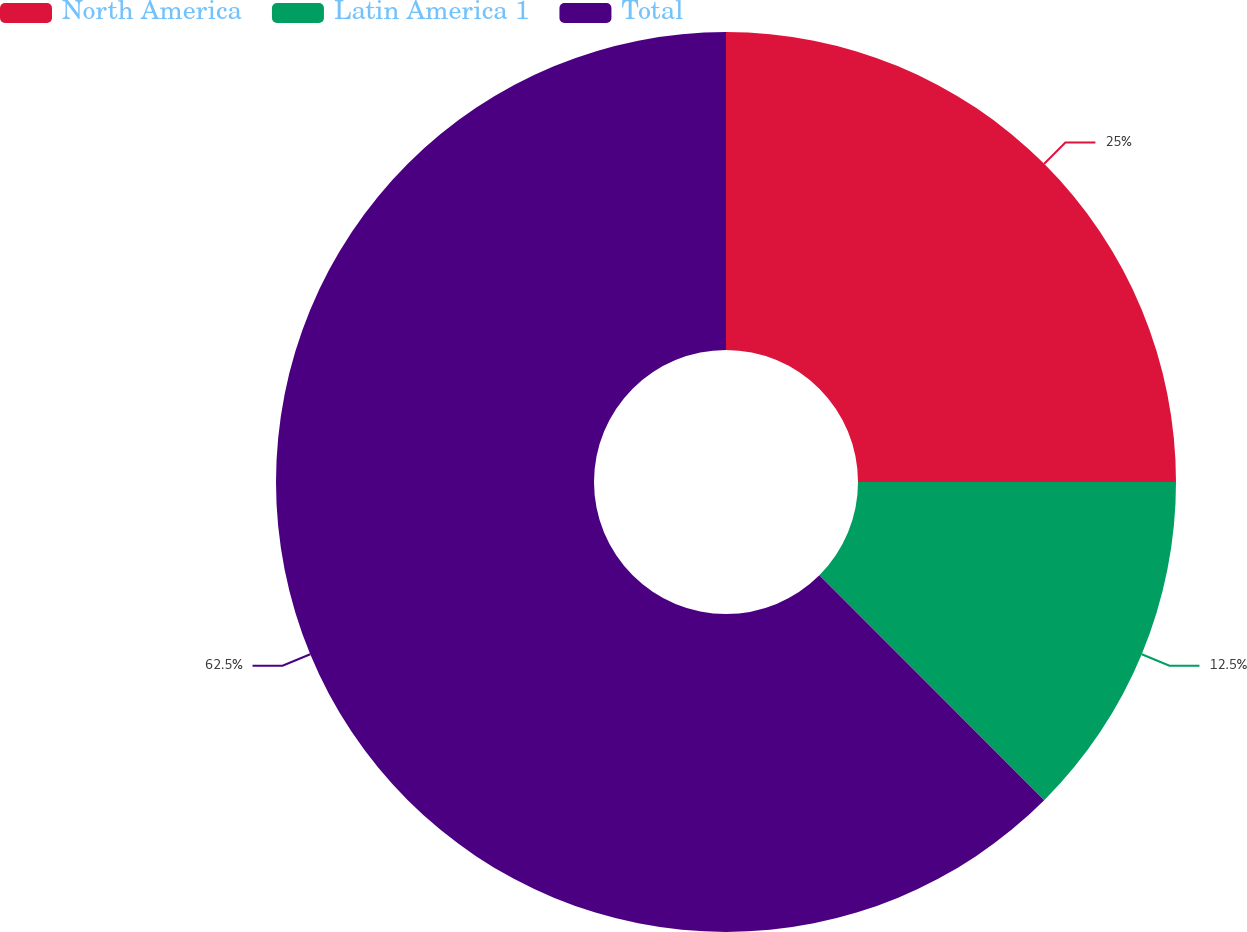Convert chart. <chart><loc_0><loc_0><loc_500><loc_500><pie_chart><fcel>North America<fcel>Latin America 1<fcel>Total<nl><fcel>25.0%<fcel>12.5%<fcel>62.5%<nl></chart> 